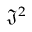<formula> <loc_0><loc_0><loc_500><loc_500>{ \mathfrak { J } } ^ { 2 }</formula> 